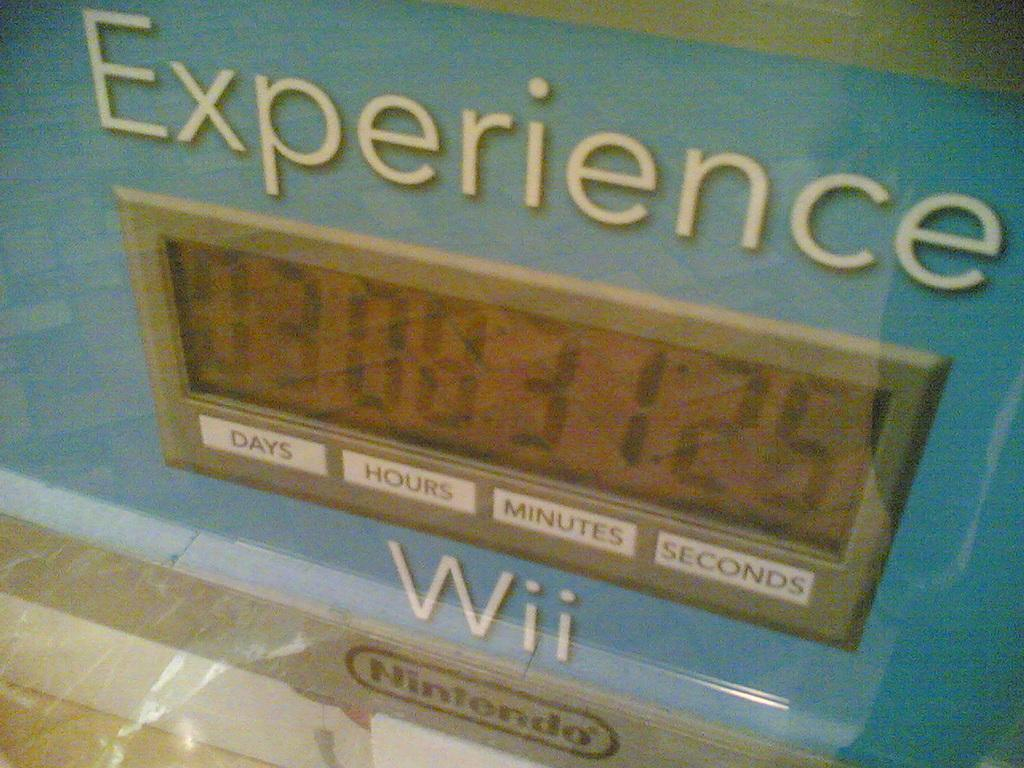<image>
Give a short and clear explanation of the subsequent image. Blue sign that says "Experience Wii" on it. 